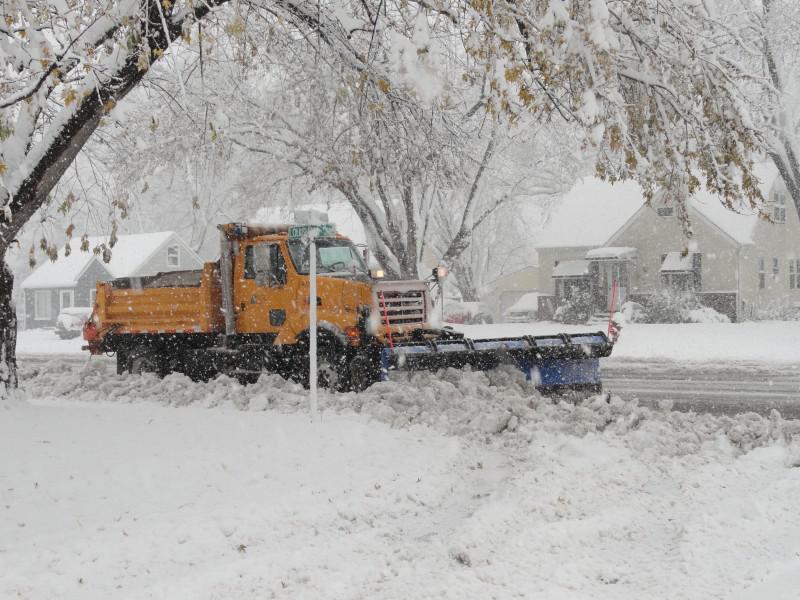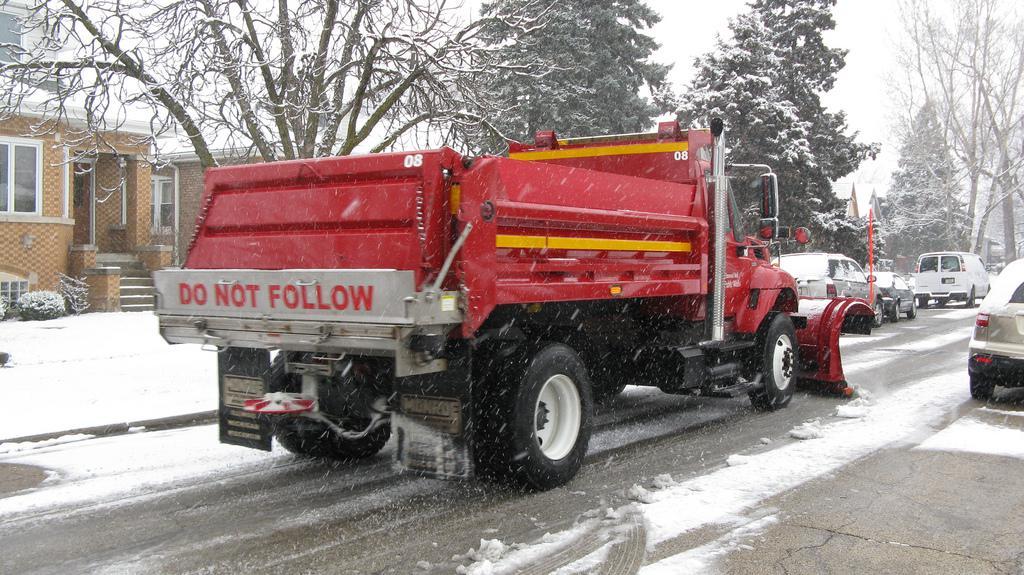The first image is the image on the left, the second image is the image on the right. For the images shown, is this caption "An image shows more than one snowplow truck on the same snowy road." true? Answer yes or no. No. 